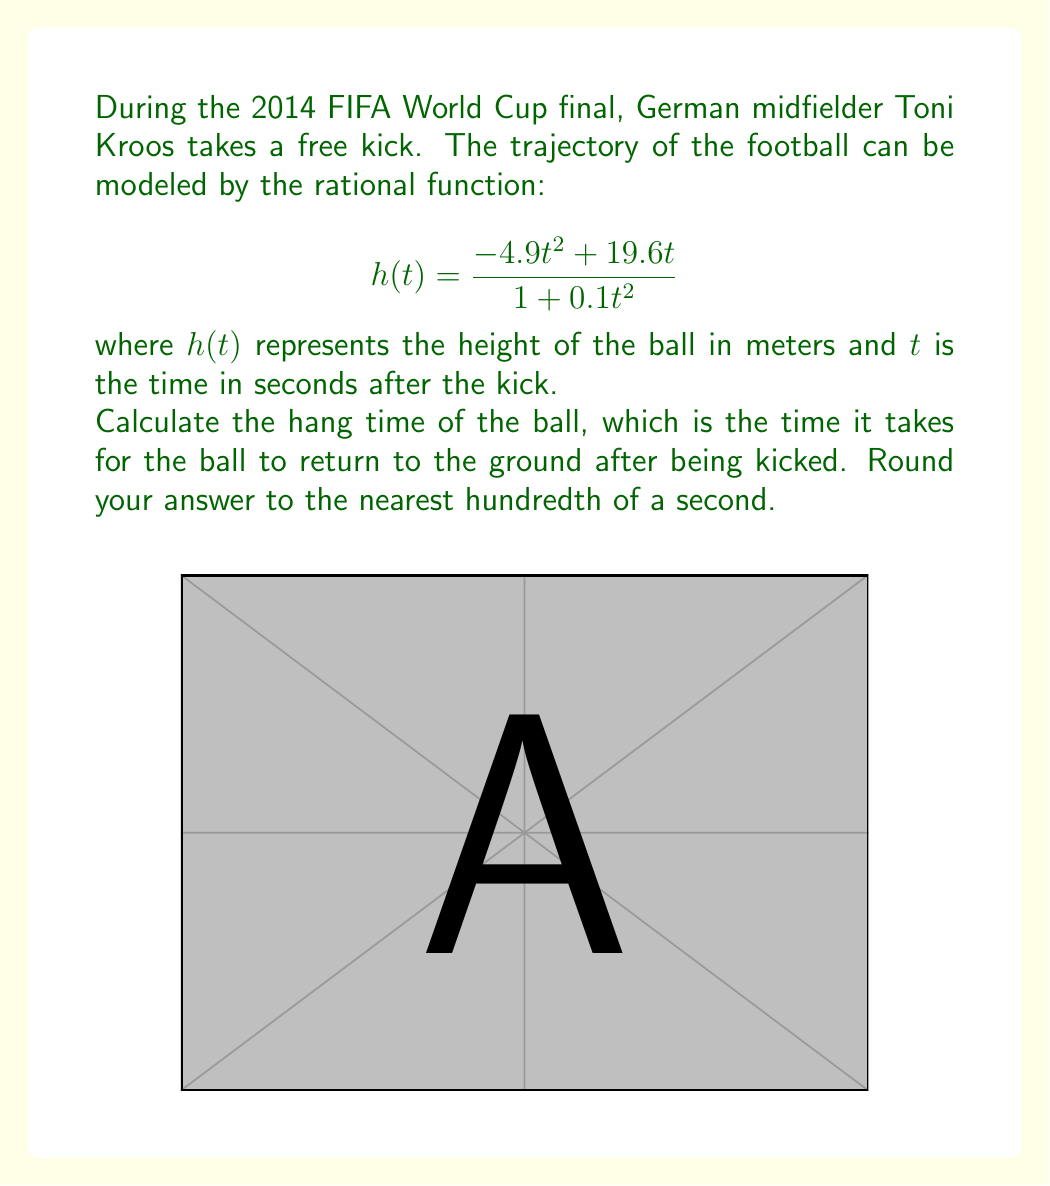Can you answer this question? Let's approach this step-by-step:

1) The hang time is the time when the ball returns to the ground. This occurs when $h(t) = 0$.

2) We need to solve the equation:

   $$\frac{-4.9t^2 + 19.6t}{1 + 0.1t^2} = 0$$

3) The numerator equals zero when:
   
   $$-4.9t^2 + 19.6t = 0$$
   $$t(-4.9t + 19.6) = 0$$

4) This equation has two solutions:
   
   $t = 0$ (when the ball is kicked)
   $-4.9t + 19.6 = 0$

5) Solving the second equation:
   
   $$-4.9t = -19.6$$
   $$t = 4$$

6) The hang time is the non-zero solution, which is 4 seconds.

7) Rounding to the nearest hundredth: 4.00 seconds.
Answer: 4.00 seconds 